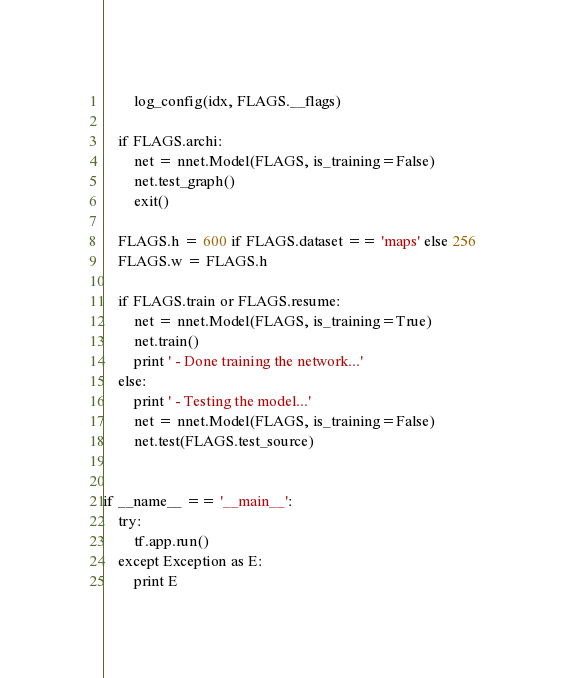<code> <loc_0><loc_0><loc_500><loc_500><_Python_>        log_config(idx, FLAGS.__flags)

    if FLAGS.archi:
        net = nnet.Model(FLAGS, is_training=False)
        net.test_graph()
        exit()

    FLAGS.h = 600 if FLAGS.dataset == 'maps' else 256
    FLAGS.w = FLAGS.h

    if FLAGS.train or FLAGS.resume:
        net = nnet.Model(FLAGS, is_training=True)
        net.train()
        print ' - Done training the network...'
    else:
        print ' - Testing the model...'
        net = nnet.Model(FLAGS, is_training=False)
        net.test(FLAGS.test_source)


if __name__ == '__main__':
    try:
        tf.app.run()
    except Exception as E:
        print E
</code> 